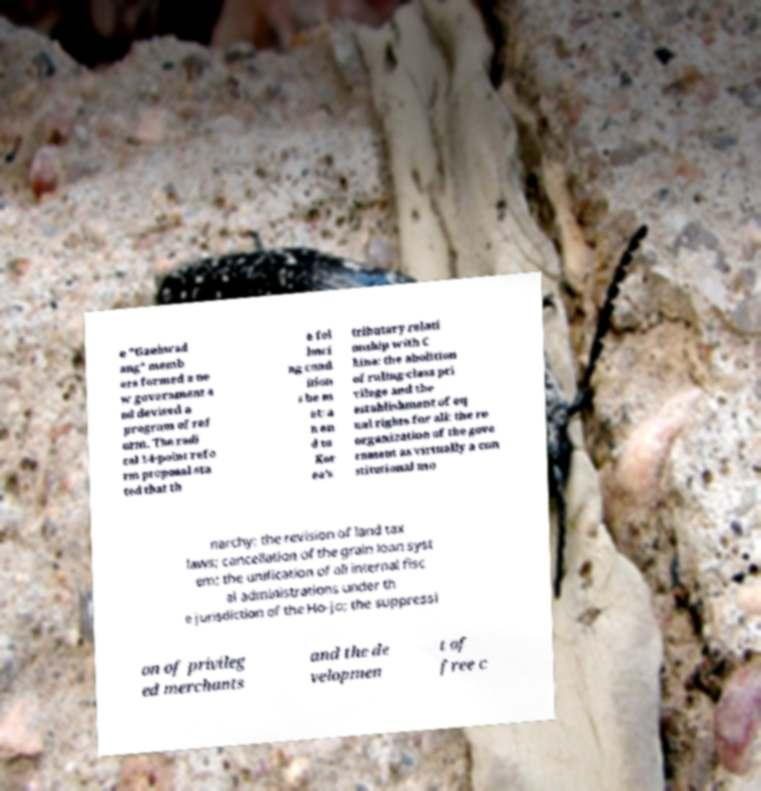For documentation purposes, I need the text within this image transcribed. Could you provide that? e "Gaehwad ang" memb ers formed a ne w government a nd devised a program of ref orm. The radi cal 14-point refo rm proposal sta ted that th e fol lowi ng cond ition s be m et: a n en d to Kor ea's tributary relati onship with C hina; the abolition of ruling-class pri vilege and the establishment of eq ual rights for all; the re organization of the gove rnment as virtually a con stitutional mo narchy; the revision of land tax laws; cancellation of the grain loan syst em; the unification of all internal fisc al administrations under th e jurisdiction of the Ho-jo; the suppressi on of privileg ed merchants and the de velopmen t of free c 